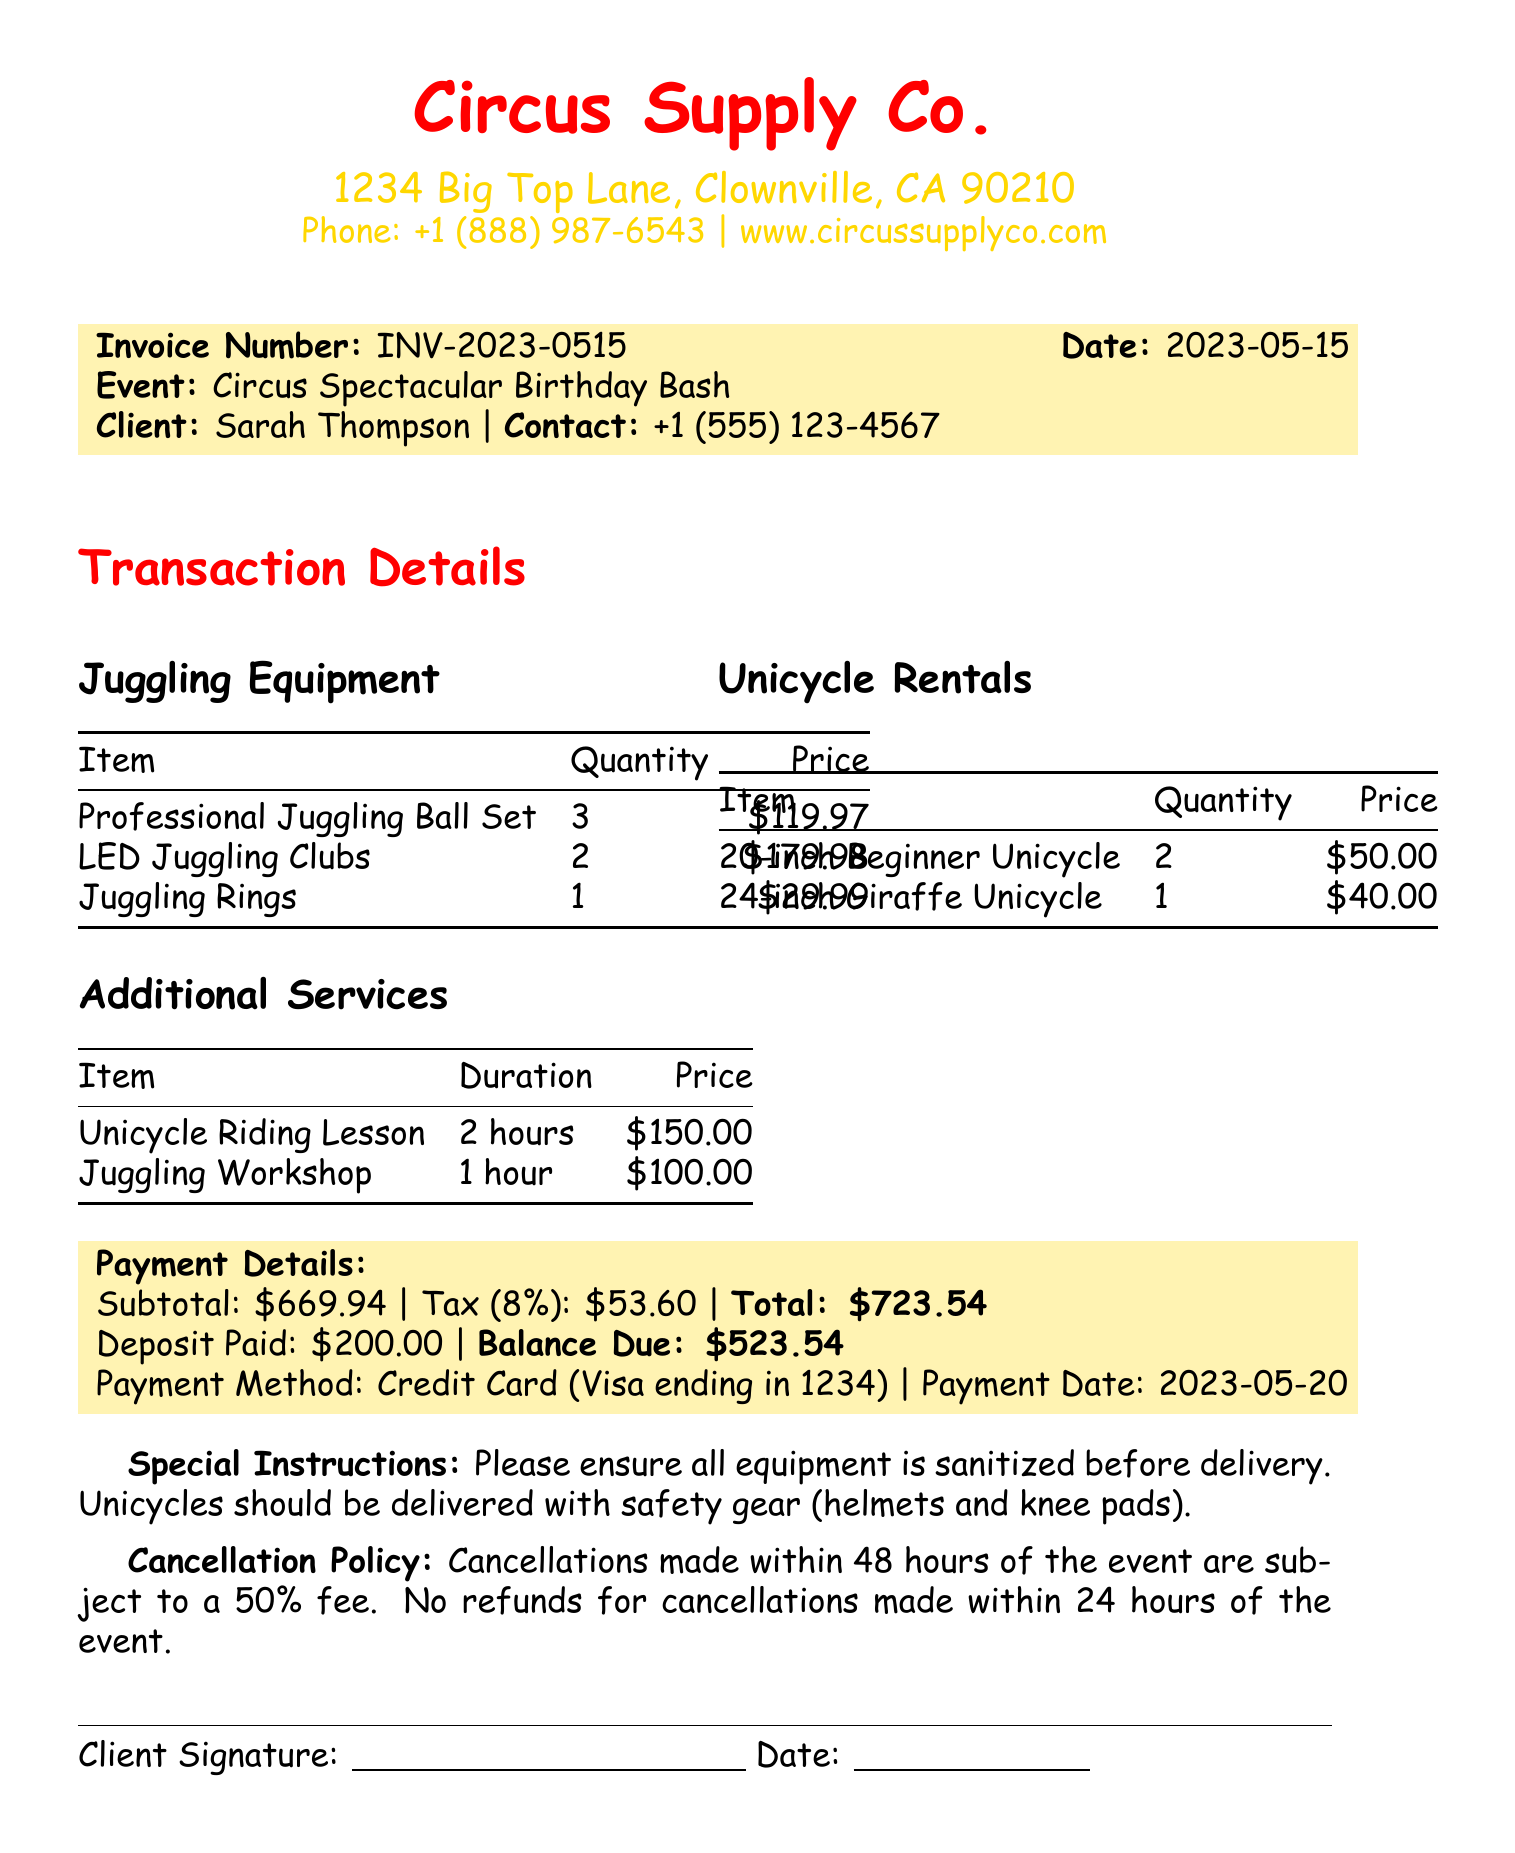What is the event name? The event name is clearly stated in the document.
Answer: Circus Spectacular Birthday Bash Who is the client? The client's name is mentioned in the transaction details.
Answer: Sarah Thompson How many LED Juggling Clubs were rented? The quantity of LED Juggling Clubs is specified in the juggling equipment section.
Answer: 2 What is the subtotal amount before tax? The subtotal is provided in the payment details section.
Answer: 669.94 What is the tax rate applied? The tax rate is indicated alongside the total payment details.
Answer: 0.08 Who is conducting the Unicycle Riding Lesson? The instructor's name is listed in the additional services section.
Answer: Max Wheeler What is the cancellation policy for the event? The cancellation policy is stated in the document.
Answer: Cancellations made within 48 hours of the event are subject to a 50% fee What item requires safety gear upon delivery? The special instructions specify items that need safety gear.
Answer: Unicycles What is the total amount due after the deposit? The balance due is included in the payment summary.
Answer: 523.54 